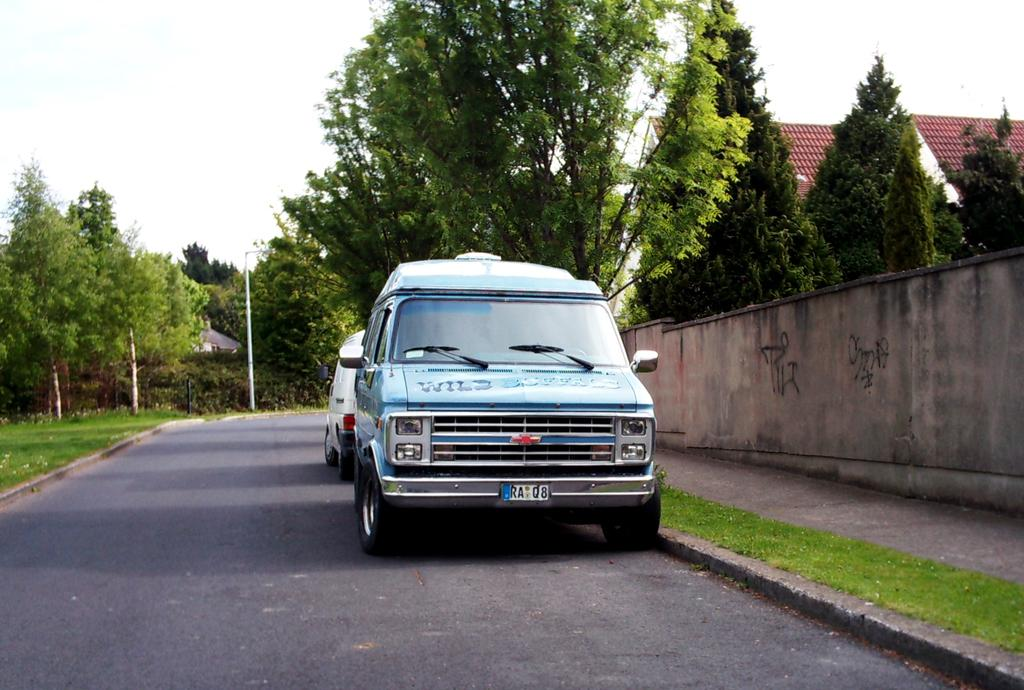What can be seen on the road in the image? There are cars on the road in the image. What is written or displayed on the wall in the image? There is text on a wall in the image. What type of vegetation is visible in the image? There is grass visible in the image, and there is also a group of trees. What type of structure can be seen in the image? There is a house with a roof in the image. What else can be seen in the image besides the house and cars? There are poles in the image. What is the condition of the sky in the image? The sky is visible in the image, and it looks cloudy. How does the government affect the cars on the road in the image? The image does not provide any information about the government or its impact on the cars on the road. What type of washing machine is visible in the image? There is no washing machine present in the image. 